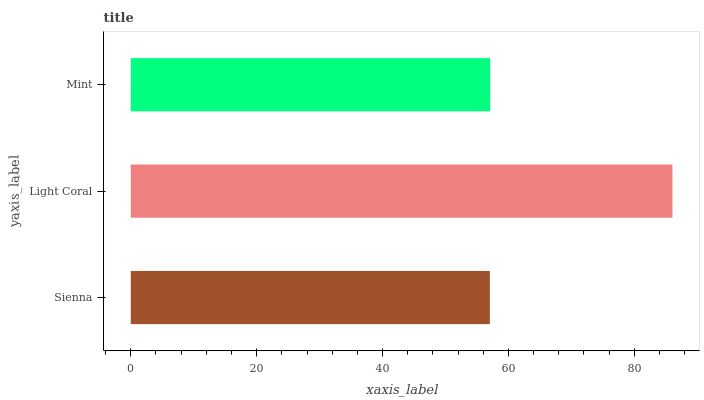Is Sienna the minimum?
Answer yes or no. Yes. Is Light Coral the maximum?
Answer yes or no. Yes. Is Mint the minimum?
Answer yes or no. No. Is Mint the maximum?
Answer yes or no. No. Is Light Coral greater than Mint?
Answer yes or no. Yes. Is Mint less than Light Coral?
Answer yes or no. Yes. Is Mint greater than Light Coral?
Answer yes or no. No. Is Light Coral less than Mint?
Answer yes or no. No. Is Mint the high median?
Answer yes or no. Yes. Is Mint the low median?
Answer yes or no. Yes. Is Light Coral the high median?
Answer yes or no. No. Is Sienna the low median?
Answer yes or no. No. 